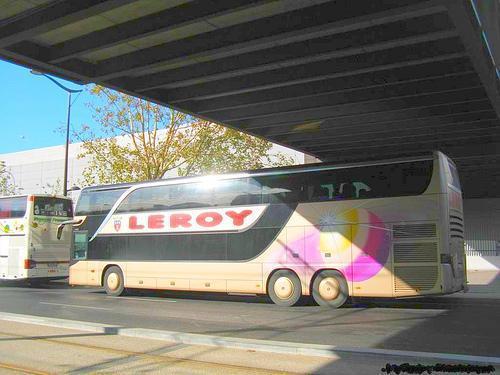How many buses can be seen?
Give a very brief answer. 3. 